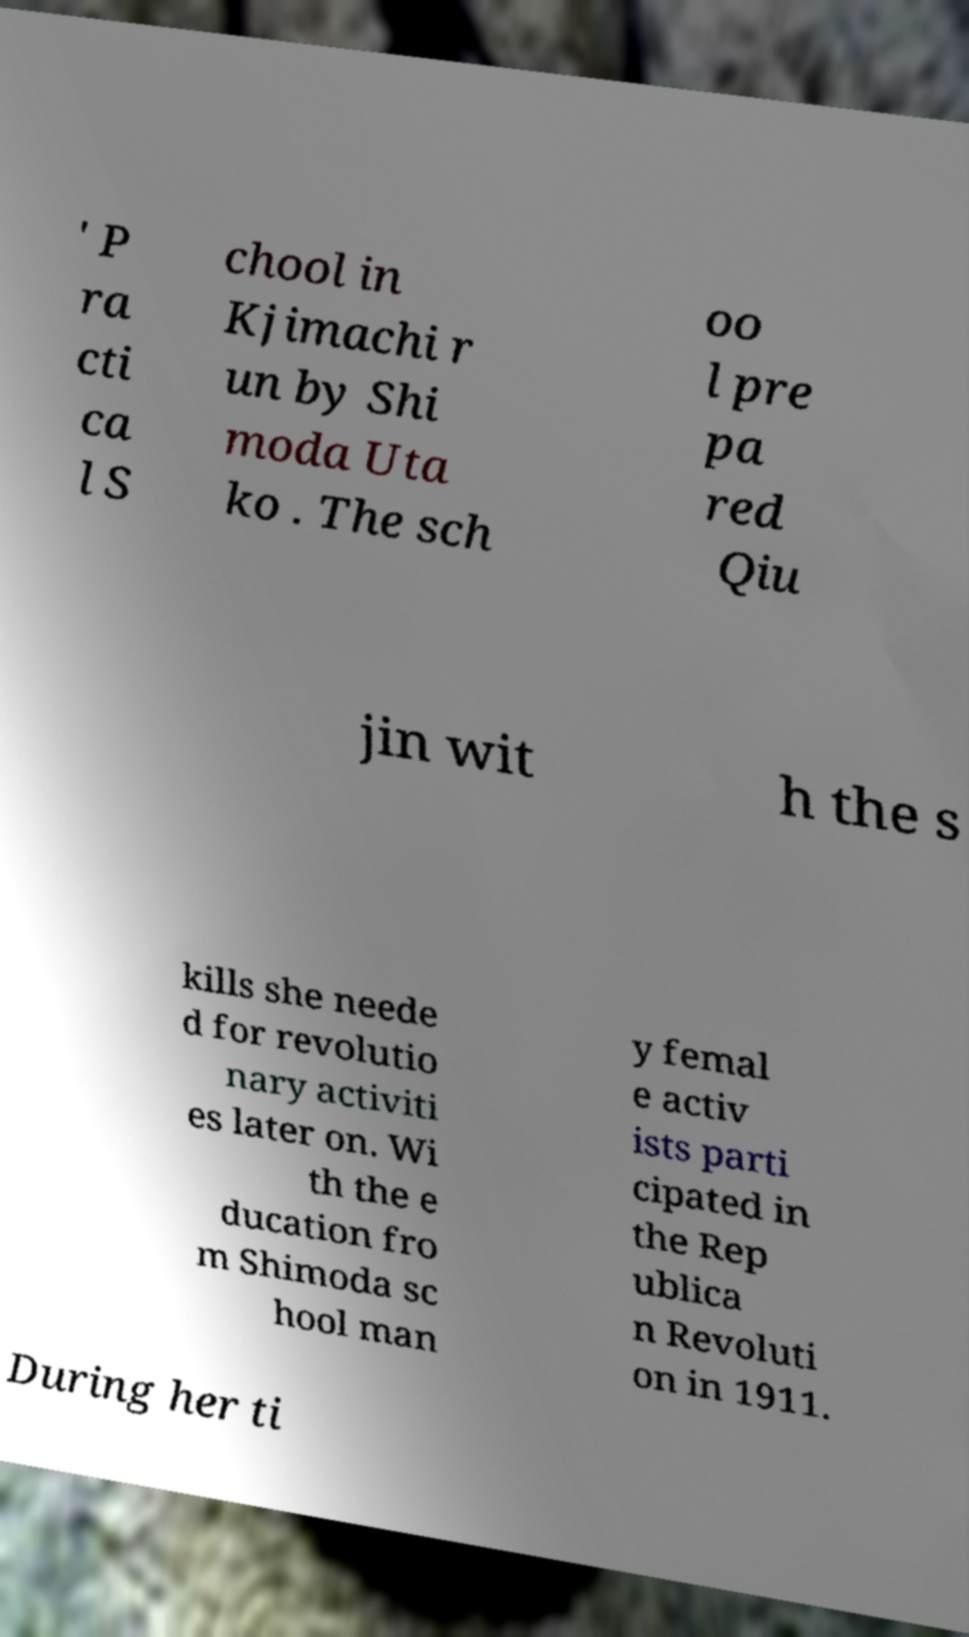What messages or text are displayed in this image? I need them in a readable, typed format. ' P ra cti ca l S chool in Kjimachi r un by Shi moda Uta ko . The sch oo l pre pa red Qiu jin wit h the s kills she neede d for revolutio nary activiti es later on. Wi th the e ducation fro m Shimoda sc hool man y femal e activ ists parti cipated in the Rep ublica n Revoluti on in 1911. During her ti 